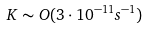<formula> <loc_0><loc_0><loc_500><loc_500>K \sim O ( 3 \cdot 1 0 ^ { - 1 1 } s ^ { - 1 } )</formula> 